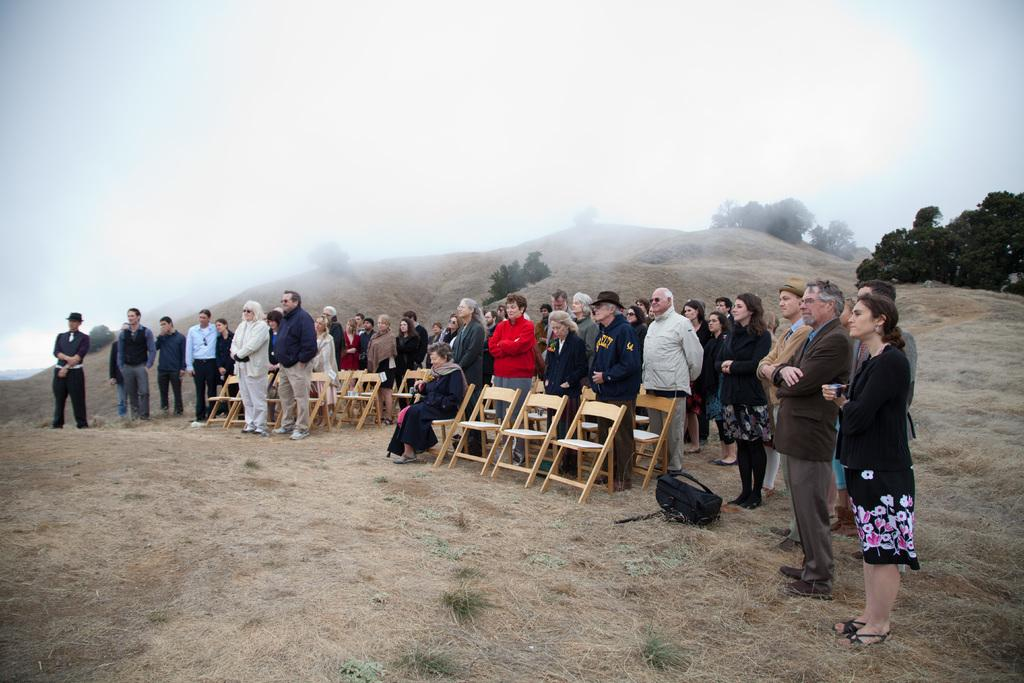How many people are in the image? There are many people in the image. What are the people in the image doing? The people are standing. Can you describe the woman in the image? There is a woman in the front of the image, and she is sitting on a chair. Where is the scene taking place? The scene takes place on a hill. What can be seen on the hill besides the people? There are trees on the hill. How would you describe the sky in the image? The sky is cloudy. What color are the eggs in the image? There are no eggs present in the image. Is there an army visible in the image? There is no army present in the image. 